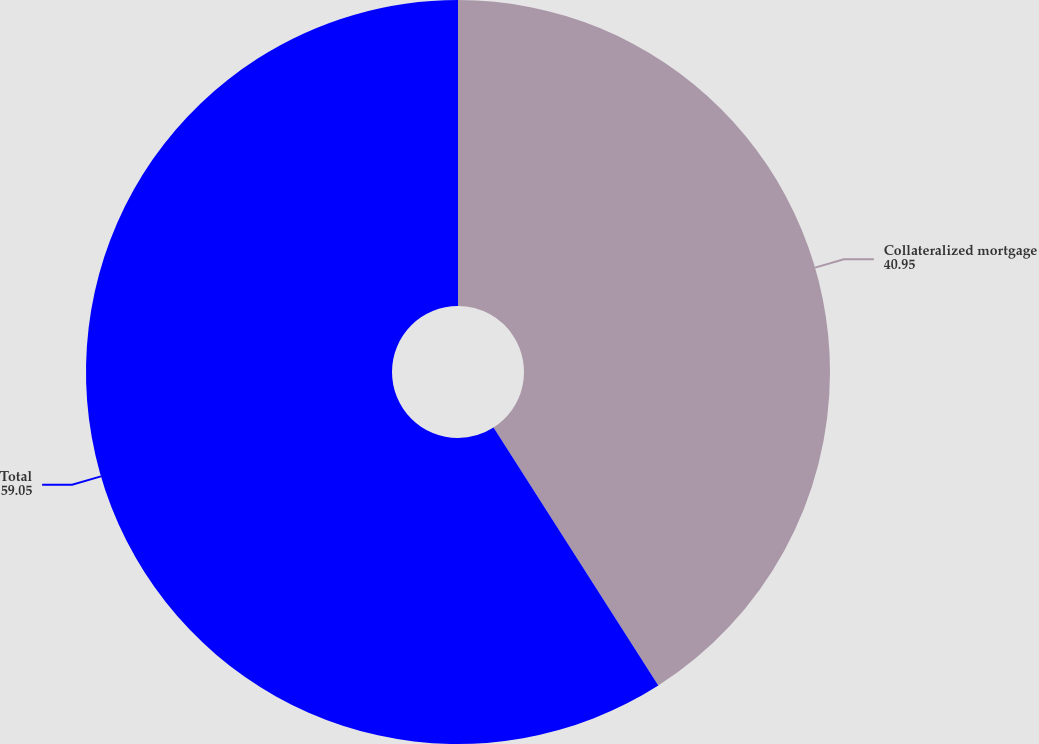Convert chart to OTSL. <chart><loc_0><loc_0><loc_500><loc_500><pie_chart><fcel>Collateralized mortgage<fcel>Total<nl><fcel>40.95%<fcel>59.05%<nl></chart> 